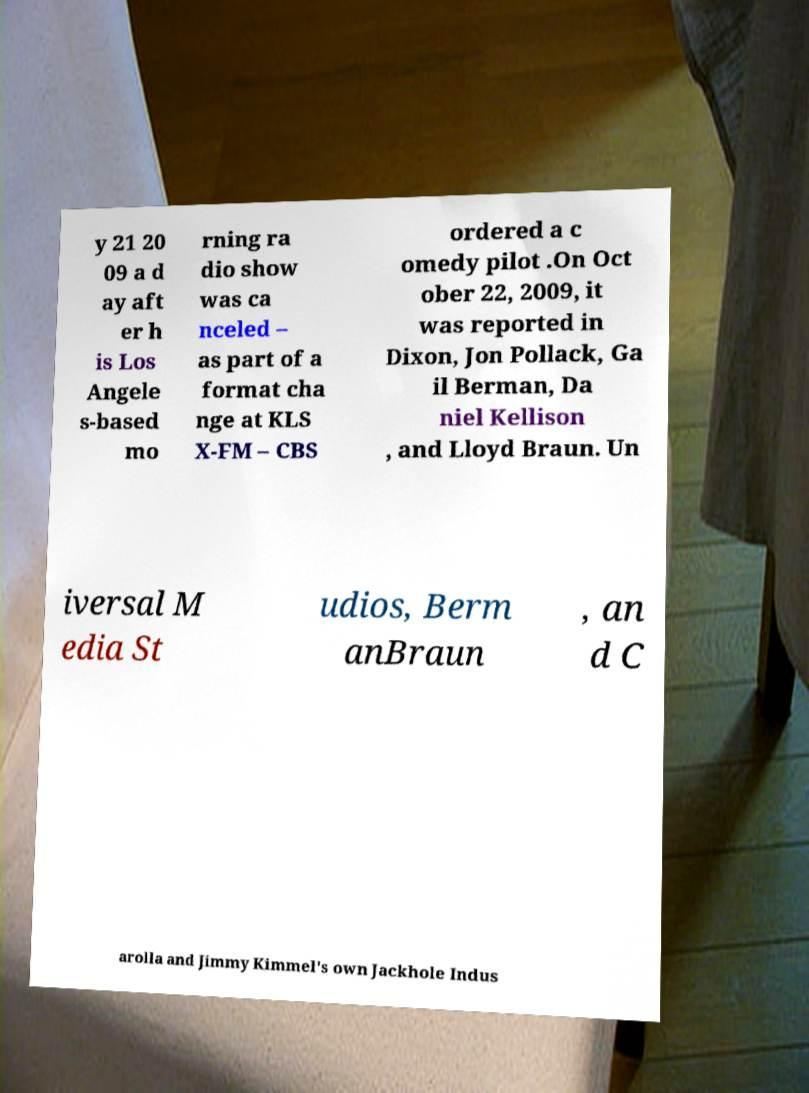Please identify and transcribe the text found in this image. y 21 20 09 a d ay aft er h is Los Angele s-based mo rning ra dio show was ca nceled – as part of a format cha nge at KLS X-FM – CBS ordered a c omedy pilot .On Oct ober 22, 2009, it was reported in Dixon, Jon Pollack, Ga il Berman, Da niel Kellison , and Lloyd Braun. Un iversal M edia St udios, Berm anBraun , an d C arolla and Jimmy Kimmel's own Jackhole Indus 